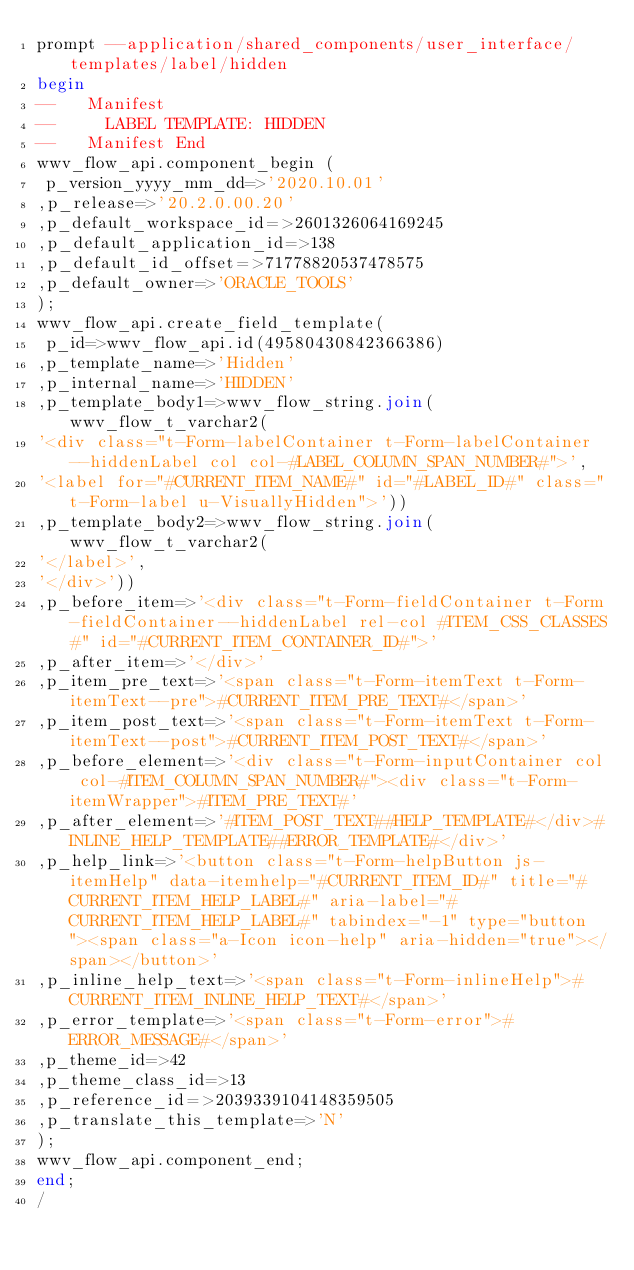<code> <loc_0><loc_0><loc_500><loc_500><_SQL_>prompt --application/shared_components/user_interface/templates/label/hidden
begin
--   Manifest
--     LABEL TEMPLATE: HIDDEN
--   Manifest End
wwv_flow_api.component_begin (
 p_version_yyyy_mm_dd=>'2020.10.01'
,p_release=>'20.2.0.00.20'
,p_default_workspace_id=>2601326064169245
,p_default_application_id=>138
,p_default_id_offset=>71778820537478575
,p_default_owner=>'ORACLE_TOOLS'
);
wwv_flow_api.create_field_template(
 p_id=>wwv_flow_api.id(49580430842366386)
,p_template_name=>'Hidden'
,p_internal_name=>'HIDDEN'
,p_template_body1=>wwv_flow_string.join(wwv_flow_t_varchar2(
'<div class="t-Form-labelContainer t-Form-labelContainer--hiddenLabel col col-#LABEL_COLUMN_SPAN_NUMBER#">',
'<label for="#CURRENT_ITEM_NAME#" id="#LABEL_ID#" class="t-Form-label u-VisuallyHidden">'))
,p_template_body2=>wwv_flow_string.join(wwv_flow_t_varchar2(
'</label>',
'</div>'))
,p_before_item=>'<div class="t-Form-fieldContainer t-Form-fieldContainer--hiddenLabel rel-col #ITEM_CSS_CLASSES#" id="#CURRENT_ITEM_CONTAINER_ID#">'
,p_after_item=>'</div>'
,p_item_pre_text=>'<span class="t-Form-itemText t-Form-itemText--pre">#CURRENT_ITEM_PRE_TEXT#</span>'
,p_item_post_text=>'<span class="t-Form-itemText t-Form-itemText--post">#CURRENT_ITEM_POST_TEXT#</span>'
,p_before_element=>'<div class="t-Form-inputContainer col col-#ITEM_COLUMN_SPAN_NUMBER#"><div class="t-Form-itemWrapper">#ITEM_PRE_TEXT#'
,p_after_element=>'#ITEM_POST_TEXT##HELP_TEMPLATE#</div>#INLINE_HELP_TEMPLATE##ERROR_TEMPLATE#</div>'
,p_help_link=>'<button class="t-Form-helpButton js-itemHelp" data-itemhelp="#CURRENT_ITEM_ID#" title="#CURRENT_ITEM_HELP_LABEL#" aria-label="#CURRENT_ITEM_HELP_LABEL#" tabindex="-1" type="button"><span class="a-Icon icon-help" aria-hidden="true"></span></button>'
,p_inline_help_text=>'<span class="t-Form-inlineHelp">#CURRENT_ITEM_INLINE_HELP_TEXT#</span>'
,p_error_template=>'<span class="t-Form-error">#ERROR_MESSAGE#</span>'
,p_theme_id=>42
,p_theme_class_id=>13
,p_reference_id=>2039339104148359505
,p_translate_this_template=>'N'
);
wwv_flow_api.component_end;
end;
/
</code> 